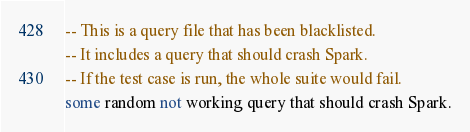Convert code to text. <code><loc_0><loc_0><loc_500><loc_500><_SQL_>-- This is a query file that has been blacklisted.
-- It includes a query that should crash Spark.
-- If the test case is run, the whole suite would fail.
some random not working query that should crash Spark.
</code> 